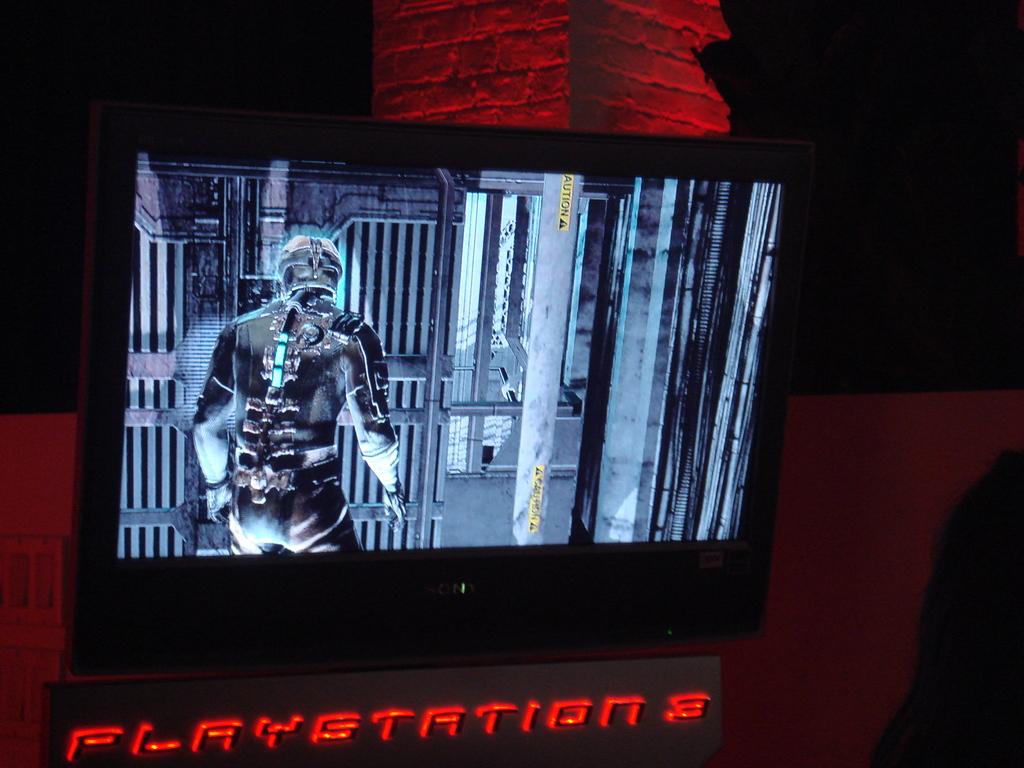Which playstation is on the sign?
Provide a short and direct response. 3. What gaming console is featured?
Your answer should be compact. Playstation 3. 